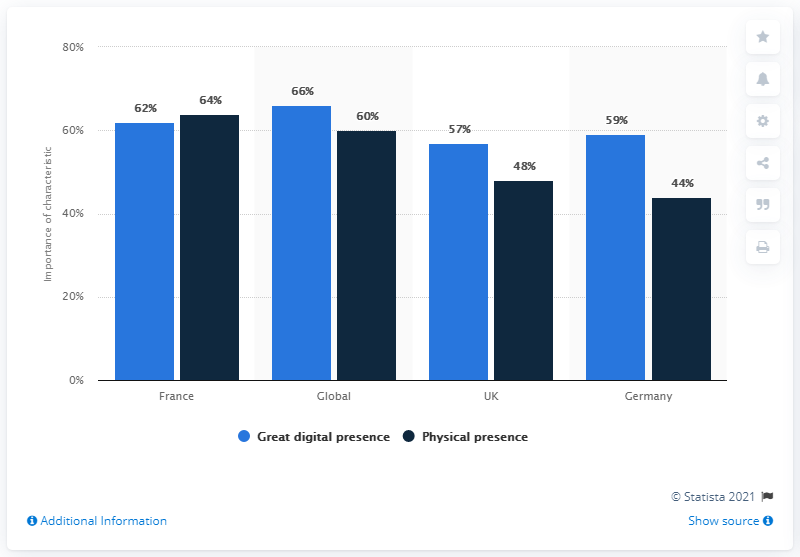List a handful of essential elements in this visual. According to the data, France was the European country with the highest importance score for the physical presence of a bank. According to a recent survey, the digital presence of businesses in the United Kingdom is currently at 57%. This indicates a high level of investment and focus on digital strategies, indicating a strong commitment to staying competitive in the digital marketplace. The sum of great digital presence and physical presence in France is 126. 